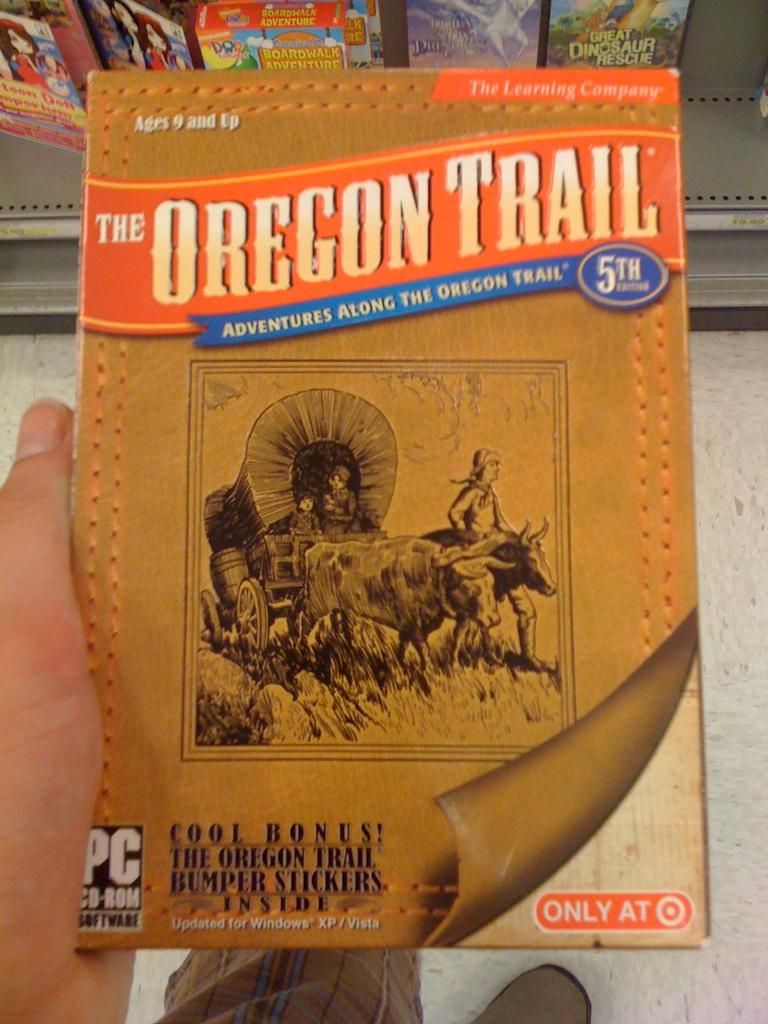<image>
Create a compact narrative representing the image presented. Someone is holding a copy of a PC game of The Oregon Trail. 